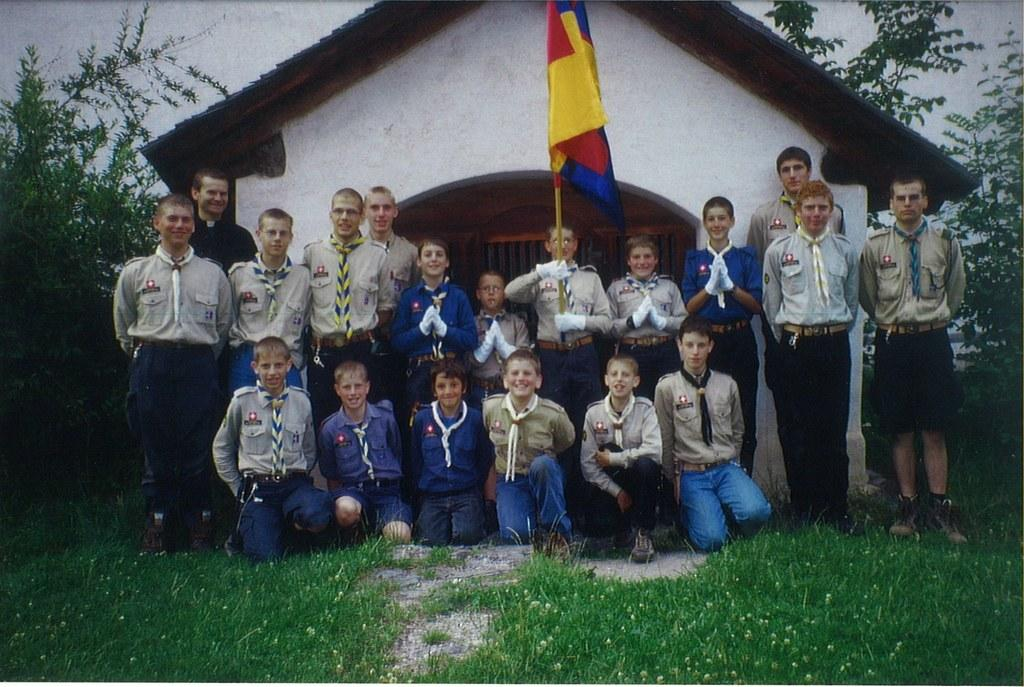What type of structure is visible in the image? There is a house in the image. What else can be seen in the image besides the house? There is a wall, trees, grass, and people in the image. Can you describe the people in the image? Yes, there is a person holding a flag, and they are standing on a path. How many pies are being turned on the side in the image? There are no pies present in the image. What type of side activity is happening in the image? There is no side activity mentioned in the image; the focus is on the house, wall, trees, grass, people, and the person holding the flag. 